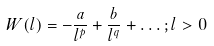Convert formula to latex. <formula><loc_0><loc_0><loc_500><loc_500>W ( l ) = - \frac { a } { l ^ { p } } + \frac { b } { l ^ { q } } + \dots ; l > 0</formula> 